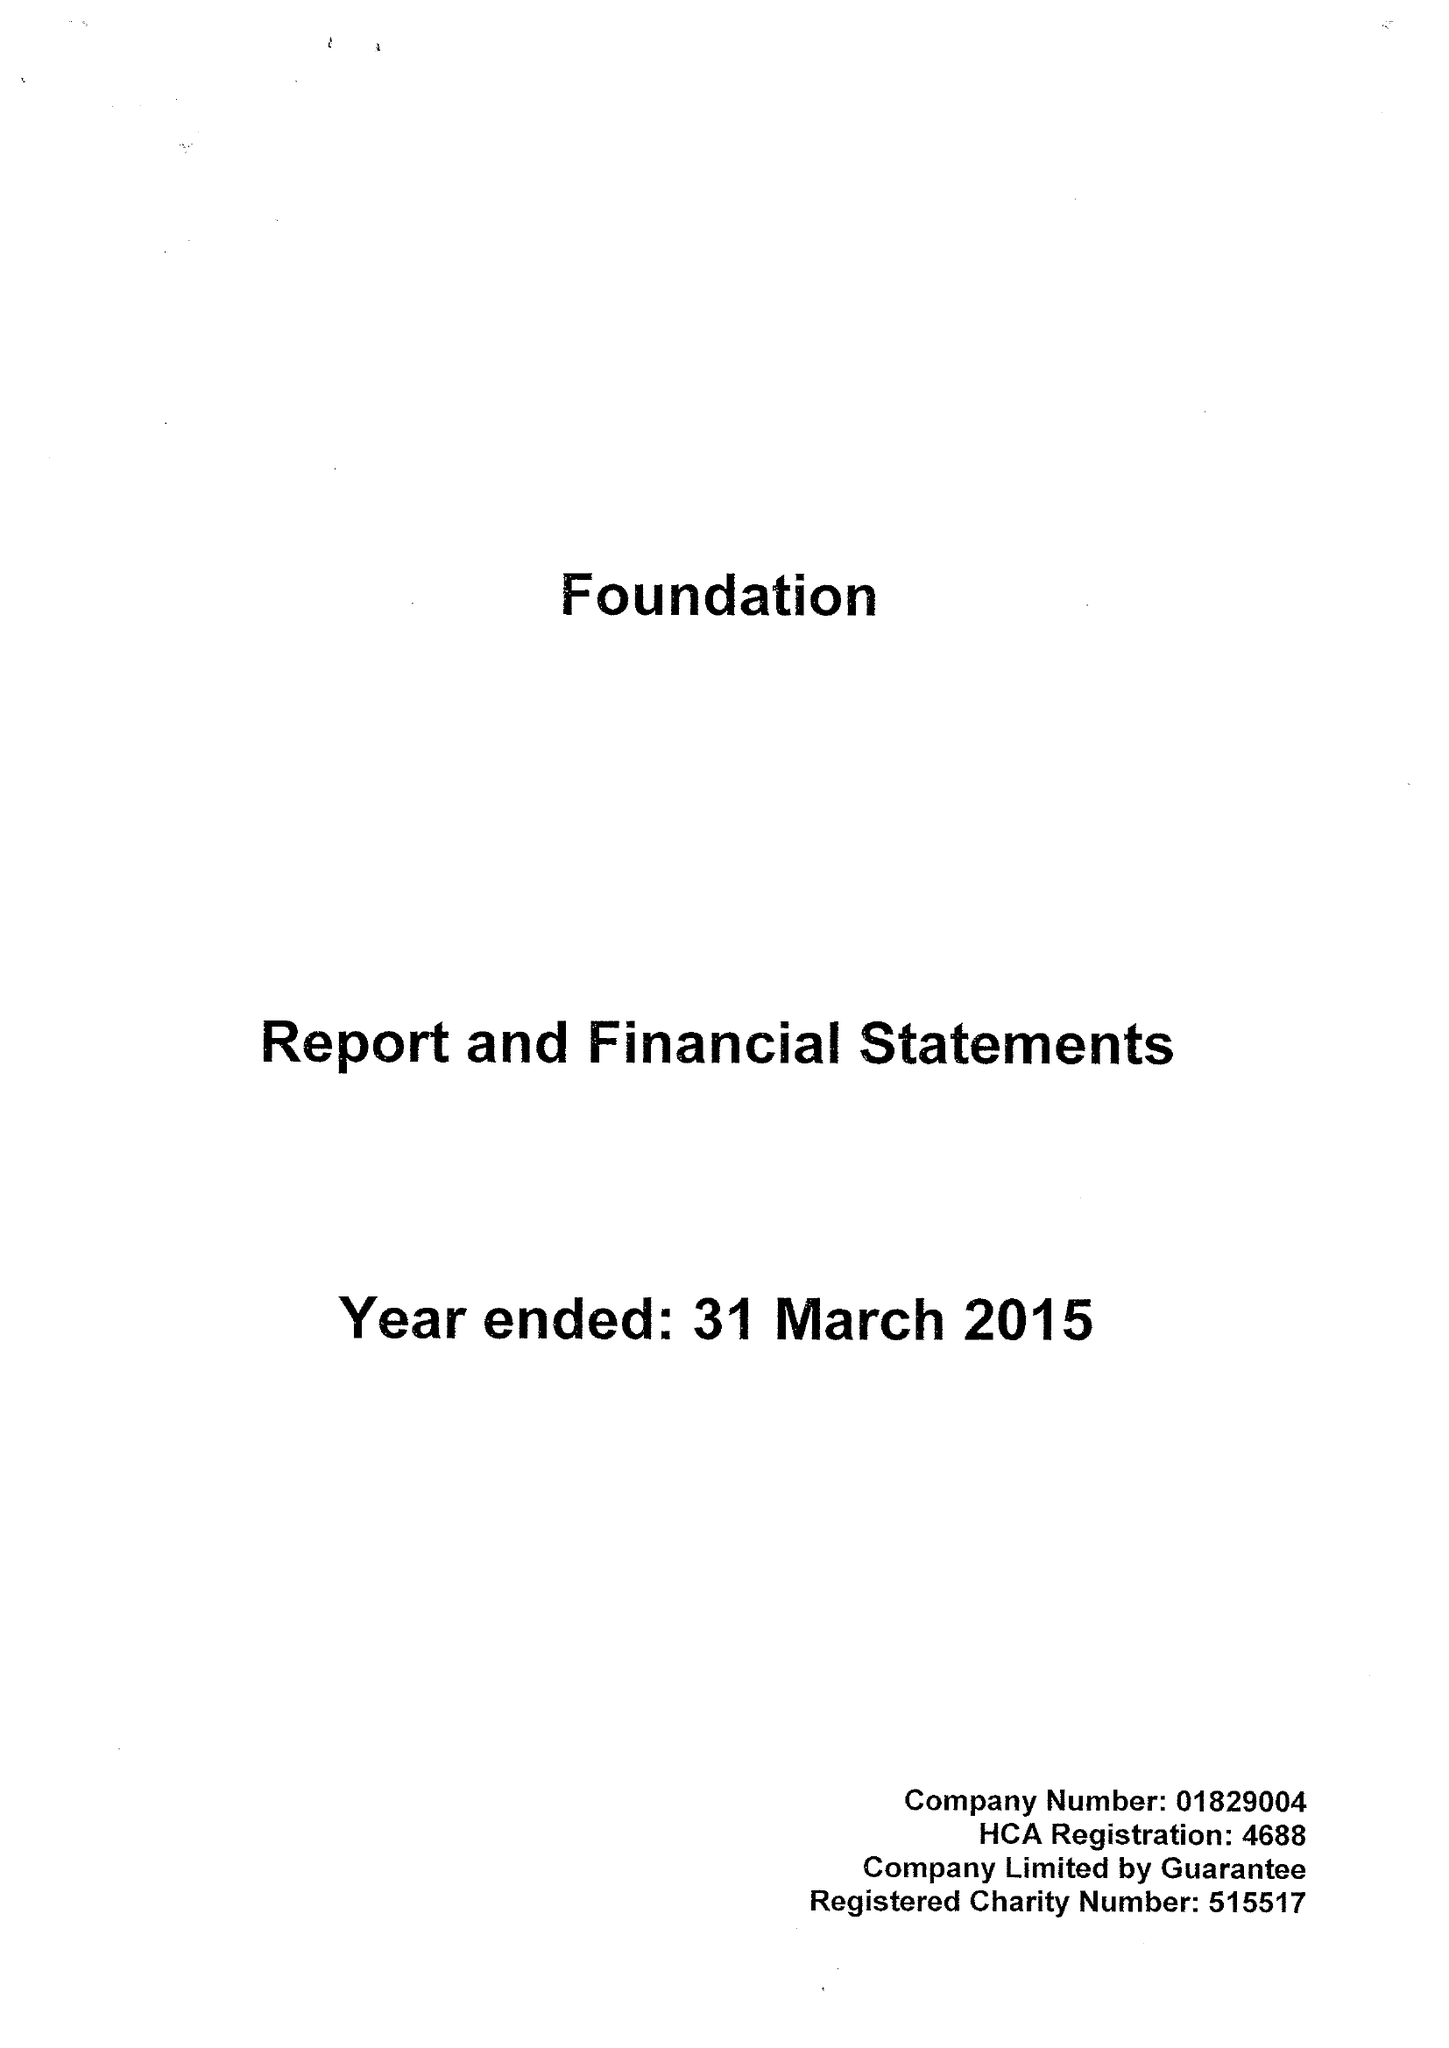What is the value for the address__postcode?
Answer the question using a single word or phrase. LS14 1AB 